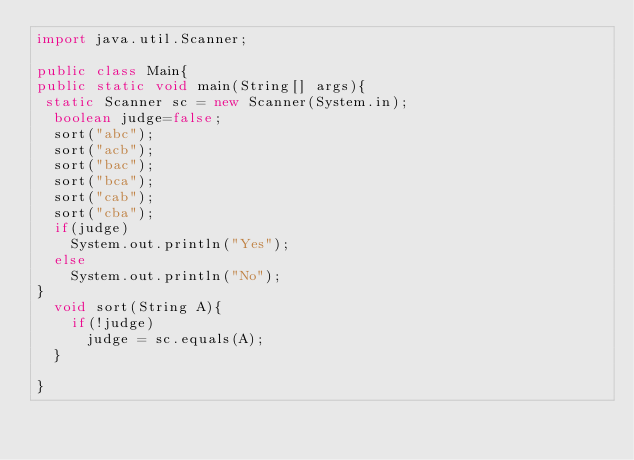<code> <loc_0><loc_0><loc_500><loc_500><_Java_>import java.util.Scanner;

public class Main{
public static void main(String[] args){
 static Scanner sc = new Scanner(System.in);
  boolean judge=false;
  sort("abc");
  sort("acb");
  sort("bac");
  sort("bca");
  sort("cab");
  sort("cba");
  if(judge)
    System.out.println("Yes");
  else
    System.out.println("No");
}
  void sort(String A){
    if(!judge)
      judge = sc.equals(A);
  }
  
}</code> 